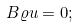<formula> <loc_0><loc_0><loc_500><loc_500>B \varrho u = 0 ;</formula> 